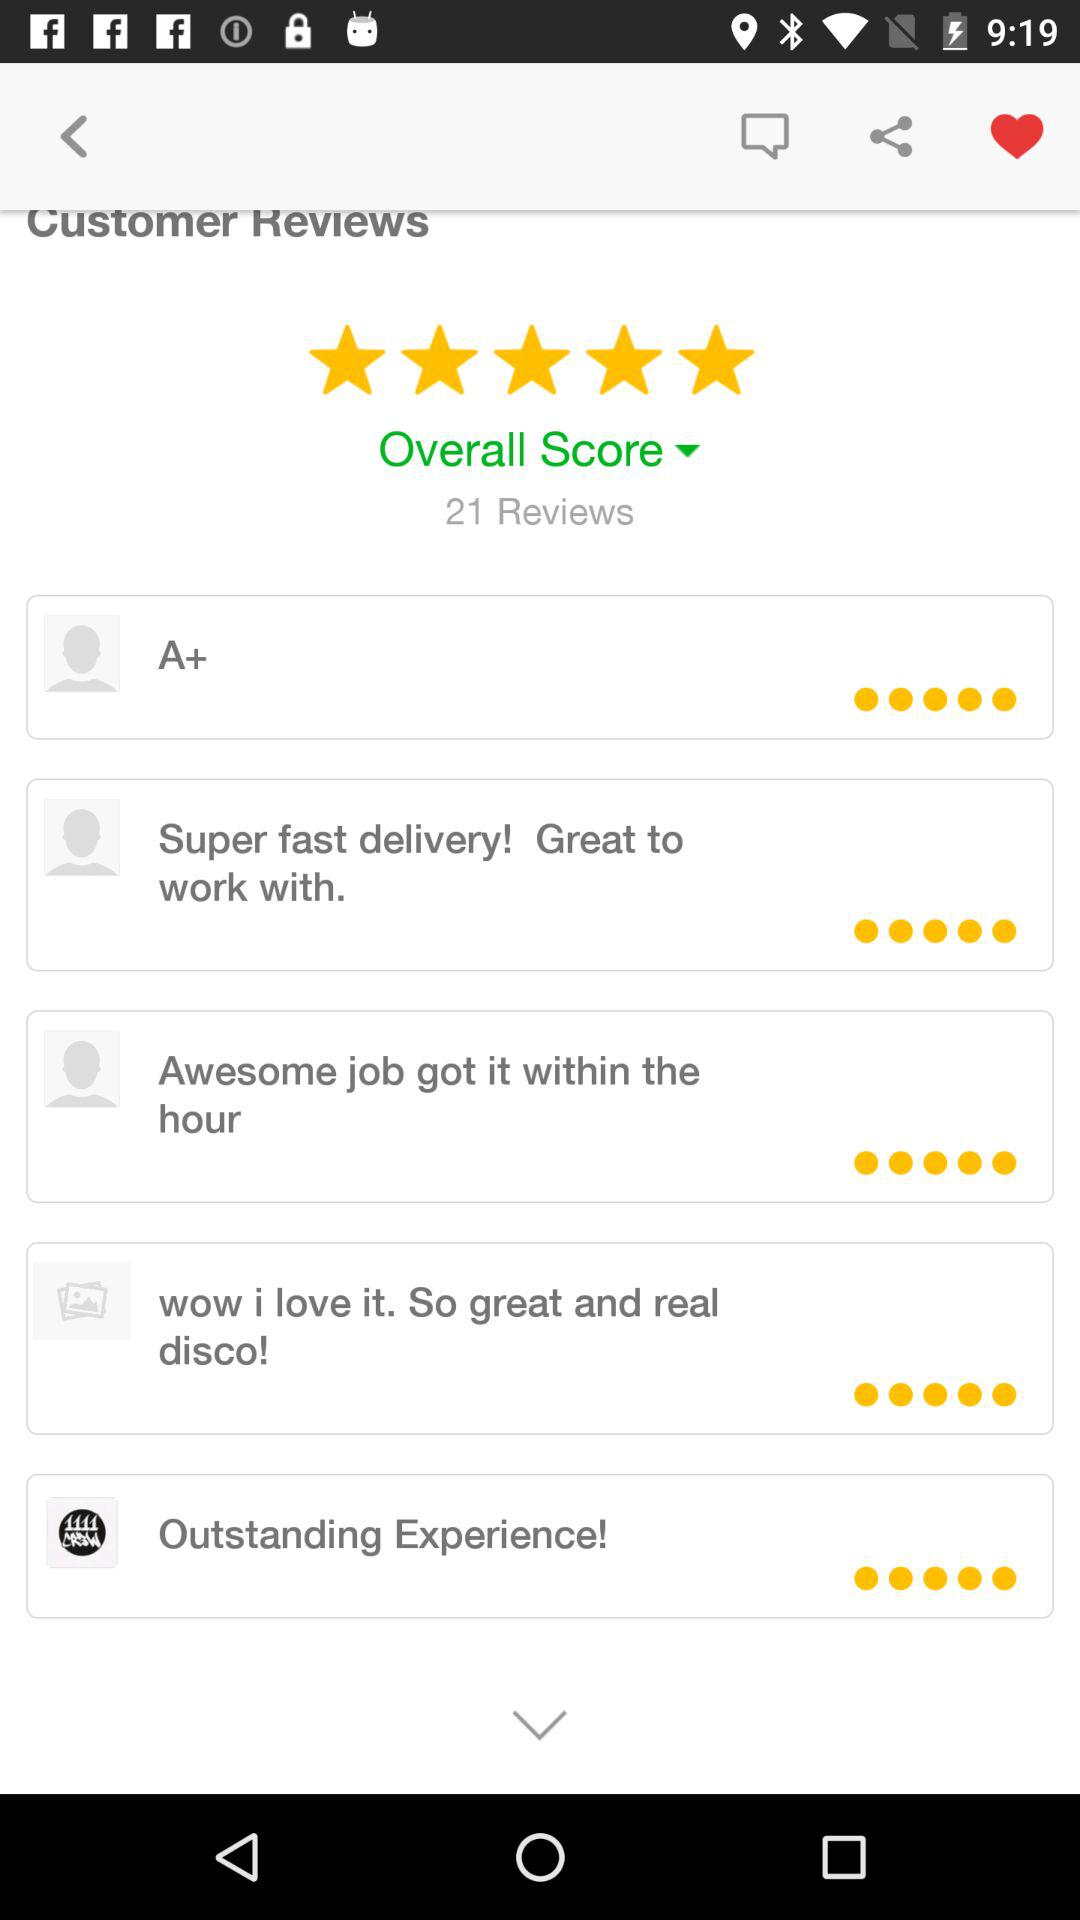How many reviews in total are there? There are 21 reviews. 